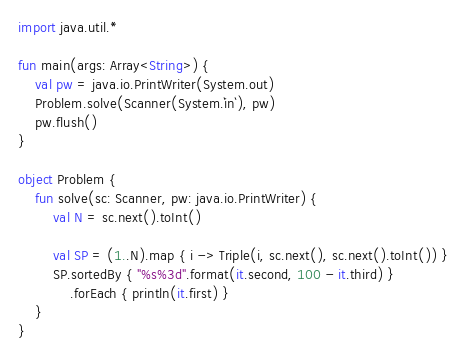<code> <loc_0><loc_0><loc_500><loc_500><_Kotlin_>import java.util.*

fun main(args: Array<String>) {
    val pw = java.io.PrintWriter(System.out)
    Problem.solve(Scanner(System.`in`), pw)
    pw.flush()
}

object Problem {
    fun solve(sc: Scanner, pw: java.io.PrintWriter) {
        val N = sc.next().toInt()

        val SP = (1..N).map { i -> Triple(i, sc.next(), sc.next().toInt()) }
        SP.sortedBy { "%s%3d".format(it.second, 100 - it.third) }
            .forEach { println(it.first) }
    }
}
</code> 